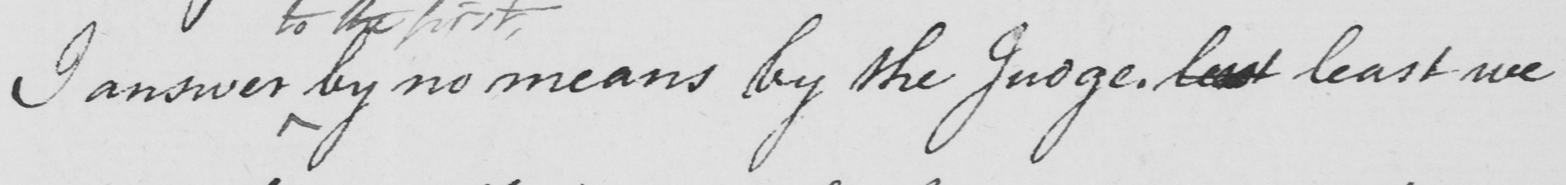Please provide the text content of this handwritten line. I answer by no means by the judge . lest least we 